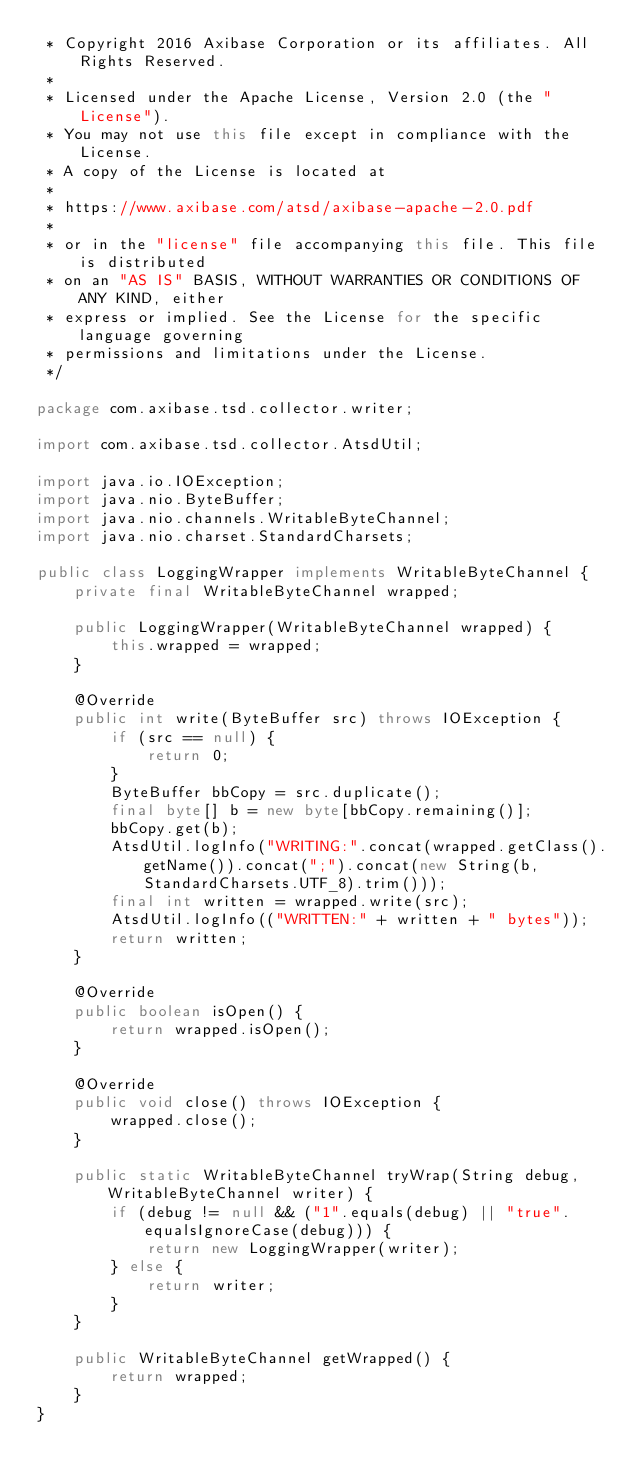<code> <loc_0><loc_0><loc_500><loc_500><_Java_> * Copyright 2016 Axibase Corporation or its affiliates. All Rights Reserved.
 *
 * Licensed under the Apache License, Version 2.0 (the "License").
 * You may not use this file except in compliance with the License.
 * A copy of the License is located at
 *
 * https://www.axibase.com/atsd/axibase-apache-2.0.pdf
 *
 * or in the "license" file accompanying this file. This file is distributed
 * on an "AS IS" BASIS, WITHOUT WARRANTIES OR CONDITIONS OF ANY KIND, either
 * express or implied. See the License for the specific language governing
 * permissions and limitations under the License.
 */

package com.axibase.tsd.collector.writer;

import com.axibase.tsd.collector.AtsdUtil;

import java.io.IOException;
import java.nio.ByteBuffer;
import java.nio.channels.WritableByteChannel;
import java.nio.charset.StandardCharsets;

public class LoggingWrapper implements WritableByteChannel {
    private final WritableByteChannel wrapped;

    public LoggingWrapper(WritableByteChannel wrapped) {
        this.wrapped = wrapped;
    }

    @Override
    public int write(ByteBuffer src) throws IOException {
        if (src == null) {
            return 0;
        }
        ByteBuffer bbCopy = src.duplicate();
        final byte[] b = new byte[bbCopy.remaining()];
        bbCopy.get(b);
        AtsdUtil.logInfo("WRITING:".concat(wrapped.getClass().getName()).concat(";").concat(new String(b, StandardCharsets.UTF_8).trim()));
        final int written = wrapped.write(src);
        AtsdUtil.logInfo(("WRITTEN:" + written + " bytes"));
        return written;
    }

    @Override
    public boolean isOpen() {
        return wrapped.isOpen();
    }

    @Override
    public void close() throws IOException {
        wrapped.close();
    }

    public static WritableByteChannel tryWrap(String debug, WritableByteChannel writer) {
        if (debug != null && ("1".equals(debug) || "true".equalsIgnoreCase(debug))) {
            return new LoggingWrapper(writer);
        } else {
            return writer;
        }
    }

    public WritableByteChannel getWrapped() {
        return wrapped;
    }
}
</code> 